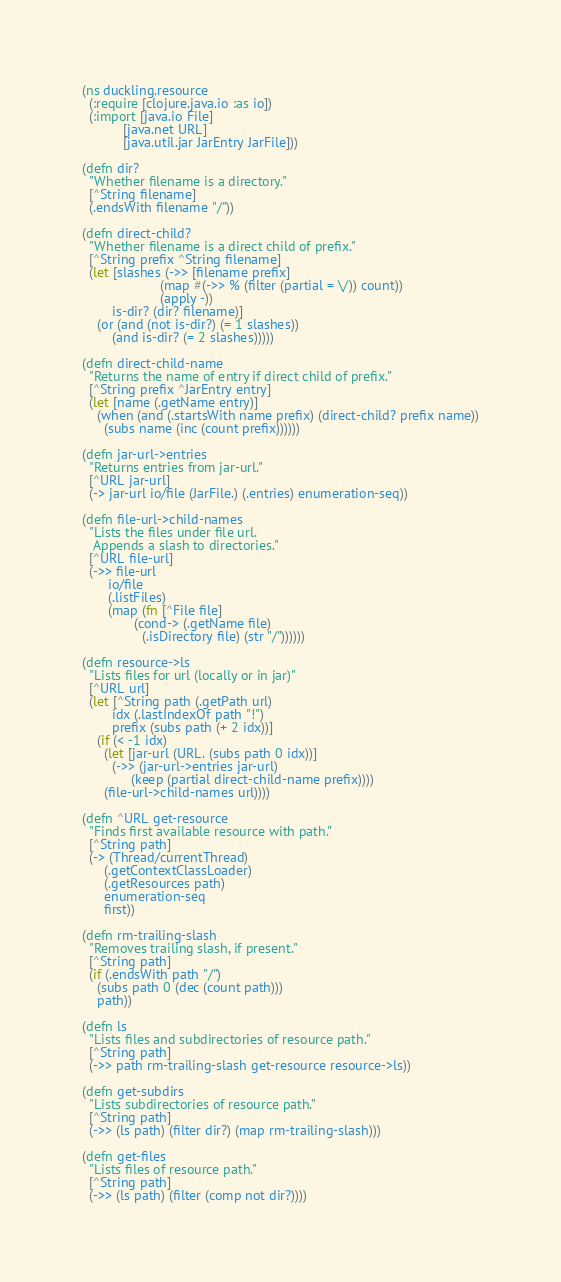Convert code to text. <code><loc_0><loc_0><loc_500><loc_500><_Clojure_>(ns duckling.resource
  (:require [clojure.java.io :as io])
  (:import [java.io File]
           [java.net URL]
           [java.util.jar JarEntry JarFile]))

(defn dir?
  "Whether filename is a directory."
  [^String filename]
  (.endsWith filename "/"))

(defn direct-child?
  "Whether filename is a direct child of prefix."
  [^String prefix ^String filename]
  (let [slashes (->> [filename prefix]
                     (map #(->> % (filter (partial = \/)) count))
                     (apply -))
        is-dir? (dir? filename)]
    (or (and (not is-dir?) (= 1 slashes))
        (and is-dir? (= 2 slashes)))))

(defn direct-child-name
  "Returns the name of entry if direct child of prefix."
  [^String prefix ^JarEntry entry]
  (let [name (.getName entry)]
    (when (and (.startsWith name prefix) (direct-child? prefix name))
      (subs name (inc (count prefix))))))

(defn jar-url->entries
  "Returns entries from jar-url."
  [^URL jar-url]
  (-> jar-url io/file (JarFile.) (.entries) enumeration-seq))

(defn file-url->child-names
  "Lists the files under file url.
   Appends a slash to directories."
  [^URL file-url]
  (->> file-url
       io/file
       (.listFiles)
       (map (fn [^File file]
              (cond-> (.getName file)
                (.isDirectory file) (str "/"))))))

(defn resource->ls
  "Lists files for url (locally or in jar)"
  [^URL url]
  (let [^String path (.getPath url)
        idx (.lastIndexOf path "!")
        prefix (subs path (+ 2 idx))]
    (if (< -1 idx)
      (let [jar-url (URL. (subs path 0 idx))]
        (->> (jar-url->entries jar-url)
             (keep (partial direct-child-name prefix))))
      (file-url->child-names url))))

(defn ^URL get-resource
  "Finds first available resource with path."
  [^String path]
  (-> (Thread/currentThread)
      (.getContextClassLoader)
      (.getResources path)
      enumeration-seq
      first))

(defn rm-trailing-slash
  "Removes trailing slash, if present."
  [^String path]
  (if (.endsWith path "/")
    (subs path 0 (dec (count path)))
    path))

(defn ls
  "Lists files and subdirectories of resource path."
  [^String path]
  (->> path rm-trailing-slash get-resource resource->ls))

(defn get-subdirs
  "Lists subdirectories of resource path."
  [^String path]
  (->> (ls path) (filter dir?) (map rm-trailing-slash)))

(defn get-files
  "Lists files of resource path."
  [^String path]
  (->> (ls path) (filter (comp not dir?))))
</code> 